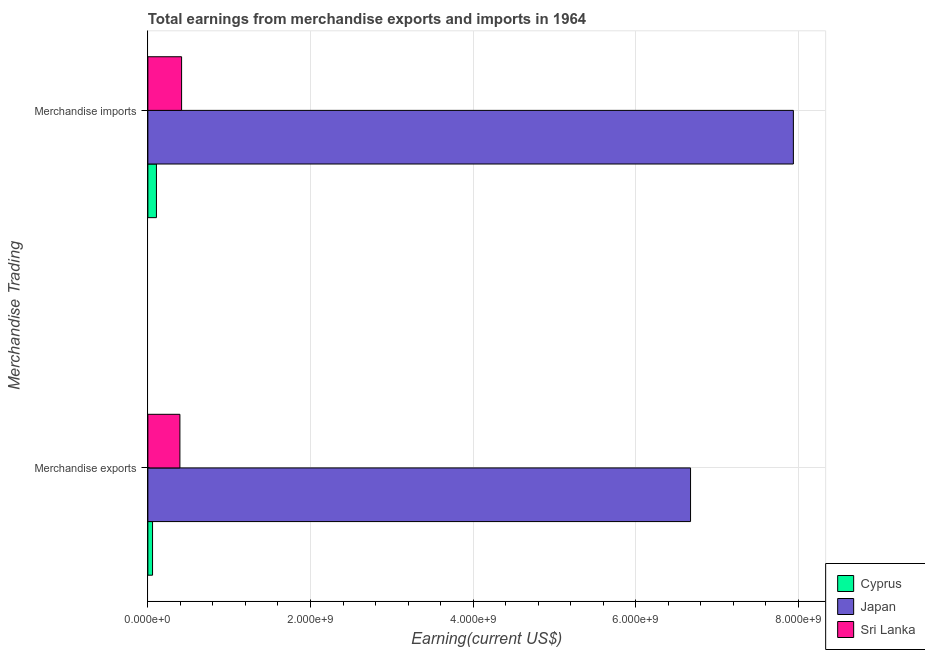How many groups of bars are there?
Provide a succinct answer. 2. How many bars are there on the 2nd tick from the bottom?
Give a very brief answer. 3. What is the label of the 2nd group of bars from the top?
Make the answer very short. Merchandise exports. What is the earnings from merchandise exports in Japan?
Keep it short and to the point. 6.67e+09. Across all countries, what is the maximum earnings from merchandise imports?
Provide a succinct answer. 7.94e+09. Across all countries, what is the minimum earnings from merchandise imports?
Your answer should be compact. 1.05e+08. In which country was the earnings from merchandise imports maximum?
Give a very brief answer. Japan. In which country was the earnings from merchandise exports minimum?
Provide a short and direct response. Cyprus. What is the total earnings from merchandise imports in the graph?
Offer a very short reply. 8.46e+09. What is the difference between the earnings from merchandise exports in Cyprus and that in Japan?
Make the answer very short. -6.62e+09. What is the difference between the earnings from merchandise exports in Japan and the earnings from merchandise imports in Cyprus?
Your answer should be compact. 6.57e+09. What is the average earnings from merchandise imports per country?
Make the answer very short. 2.82e+09. What is the difference between the earnings from merchandise exports and earnings from merchandise imports in Japan?
Your answer should be compact. -1.26e+09. What is the ratio of the earnings from merchandise imports in Japan to that in Sri Lanka?
Offer a very short reply. 19.14. Is the earnings from merchandise imports in Sri Lanka less than that in Japan?
Offer a terse response. Yes. What does the 3rd bar from the bottom in Merchandise exports represents?
Provide a short and direct response. Sri Lanka. Are all the bars in the graph horizontal?
Your answer should be very brief. Yes. What is the difference between two consecutive major ticks on the X-axis?
Keep it short and to the point. 2.00e+09. Does the graph contain any zero values?
Your response must be concise. No. Where does the legend appear in the graph?
Your response must be concise. Bottom right. How many legend labels are there?
Your answer should be compact. 3. How are the legend labels stacked?
Give a very brief answer. Vertical. What is the title of the graph?
Offer a very short reply. Total earnings from merchandise exports and imports in 1964. Does "Botswana" appear as one of the legend labels in the graph?
Ensure brevity in your answer.  No. What is the label or title of the X-axis?
Your answer should be very brief. Earning(current US$). What is the label or title of the Y-axis?
Ensure brevity in your answer.  Merchandise Trading. What is the Earning(current US$) in Cyprus in Merchandise exports?
Your answer should be compact. 5.75e+07. What is the Earning(current US$) of Japan in Merchandise exports?
Give a very brief answer. 6.67e+09. What is the Earning(current US$) in Sri Lanka in Merchandise exports?
Provide a short and direct response. 3.94e+08. What is the Earning(current US$) of Cyprus in Merchandise imports?
Offer a terse response. 1.05e+08. What is the Earning(current US$) of Japan in Merchandise imports?
Offer a very short reply. 7.94e+09. What is the Earning(current US$) of Sri Lanka in Merchandise imports?
Your response must be concise. 4.15e+08. Across all Merchandise Trading, what is the maximum Earning(current US$) in Cyprus?
Provide a succinct answer. 1.05e+08. Across all Merchandise Trading, what is the maximum Earning(current US$) of Japan?
Offer a very short reply. 7.94e+09. Across all Merchandise Trading, what is the maximum Earning(current US$) in Sri Lanka?
Provide a short and direct response. 4.15e+08. Across all Merchandise Trading, what is the minimum Earning(current US$) in Cyprus?
Give a very brief answer. 5.75e+07. Across all Merchandise Trading, what is the minimum Earning(current US$) of Japan?
Offer a very short reply. 6.67e+09. Across all Merchandise Trading, what is the minimum Earning(current US$) in Sri Lanka?
Offer a terse response. 3.94e+08. What is the total Earning(current US$) of Cyprus in the graph?
Provide a short and direct response. 1.63e+08. What is the total Earning(current US$) in Japan in the graph?
Your answer should be compact. 1.46e+1. What is the total Earning(current US$) in Sri Lanka in the graph?
Ensure brevity in your answer.  8.09e+08. What is the difference between the Earning(current US$) in Cyprus in Merchandise exports and that in Merchandise imports?
Your answer should be compact. -4.78e+07. What is the difference between the Earning(current US$) in Japan in Merchandise exports and that in Merchandise imports?
Offer a terse response. -1.26e+09. What is the difference between the Earning(current US$) in Sri Lanka in Merchandise exports and that in Merchandise imports?
Provide a short and direct response. -2.08e+07. What is the difference between the Earning(current US$) in Cyprus in Merchandise exports and the Earning(current US$) in Japan in Merchandise imports?
Ensure brevity in your answer.  -7.88e+09. What is the difference between the Earning(current US$) of Cyprus in Merchandise exports and the Earning(current US$) of Sri Lanka in Merchandise imports?
Keep it short and to the point. -3.57e+08. What is the difference between the Earning(current US$) in Japan in Merchandise exports and the Earning(current US$) in Sri Lanka in Merchandise imports?
Offer a terse response. 6.26e+09. What is the average Earning(current US$) in Cyprus per Merchandise Trading?
Offer a terse response. 8.14e+07. What is the average Earning(current US$) of Japan per Merchandise Trading?
Give a very brief answer. 7.31e+09. What is the average Earning(current US$) in Sri Lanka per Merchandise Trading?
Your response must be concise. 4.04e+08. What is the difference between the Earning(current US$) of Cyprus and Earning(current US$) of Japan in Merchandise exports?
Give a very brief answer. -6.62e+09. What is the difference between the Earning(current US$) in Cyprus and Earning(current US$) in Sri Lanka in Merchandise exports?
Provide a short and direct response. -3.36e+08. What is the difference between the Earning(current US$) of Japan and Earning(current US$) of Sri Lanka in Merchandise exports?
Your answer should be very brief. 6.28e+09. What is the difference between the Earning(current US$) of Cyprus and Earning(current US$) of Japan in Merchandise imports?
Your answer should be very brief. -7.83e+09. What is the difference between the Earning(current US$) of Cyprus and Earning(current US$) of Sri Lanka in Merchandise imports?
Your response must be concise. -3.09e+08. What is the difference between the Earning(current US$) in Japan and Earning(current US$) in Sri Lanka in Merchandise imports?
Make the answer very short. 7.52e+09. What is the ratio of the Earning(current US$) in Cyprus in Merchandise exports to that in Merchandise imports?
Ensure brevity in your answer.  0.55. What is the ratio of the Earning(current US$) of Japan in Merchandise exports to that in Merchandise imports?
Give a very brief answer. 0.84. What is the ratio of the Earning(current US$) in Sri Lanka in Merchandise exports to that in Merchandise imports?
Provide a succinct answer. 0.95. What is the difference between the highest and the second highest Earning(current US$) of Cyprus?
Offer a very short reply. 4.78e+07. What is the difference between the highest and the second highest Earning(current US$) of Japan?
Your answer should be compact. 1.26e+09. What is the difference between the highest and the second highest Earning(current US$) in Sri Lanka?
Your response must be concise. 2.08e+07. What is the difference between the highest and the lowest Earning(current US$) in Cyprus?
Provide a short and direct response. 4.78e+07. What is the difference between the highest and the lowest Earning(current US$) of Japan?
Your answer should be compact. 1.26e+09. What is the difference between the highest and the lowest Earning(current US$) in Sri Lanka?
Give a very brief answer. 2.08e+07. 